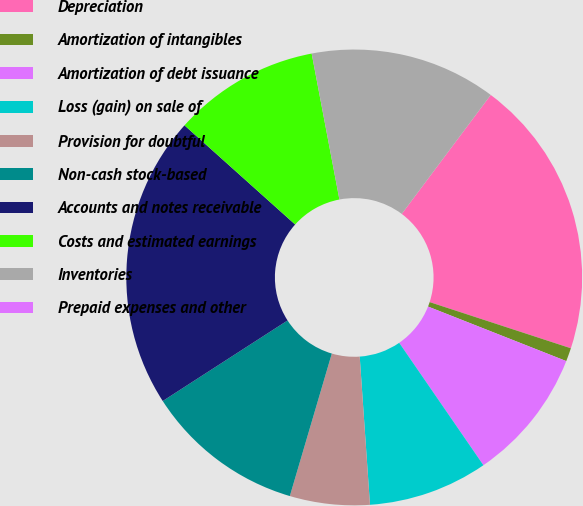Convert chart. <chart><loc_0><loc_0><loc_500><loc_500><pie_chart><fcel>Depreciation<fcel>Amortization of intangibles<fcel>Amortization of debt issuance<fcel>Loss (gain) on sale of<fcel>Provision for doubtful<fcel>Non-cash stock-based<fcel>Accounts and notes receivable<fcel>Costs and estimated earnings<fcel>Inventories<fcel>Prepaid expenses and other<nl><fcel>19.81%<fcel>0.95%<fcel>9.43%<fcel>8.49%<fcel>5.66%<fcel>11.32%<fcel>20.75%<fcel>10.38%<fcel>13.21%<fcel>0.0%<nl></chart> 